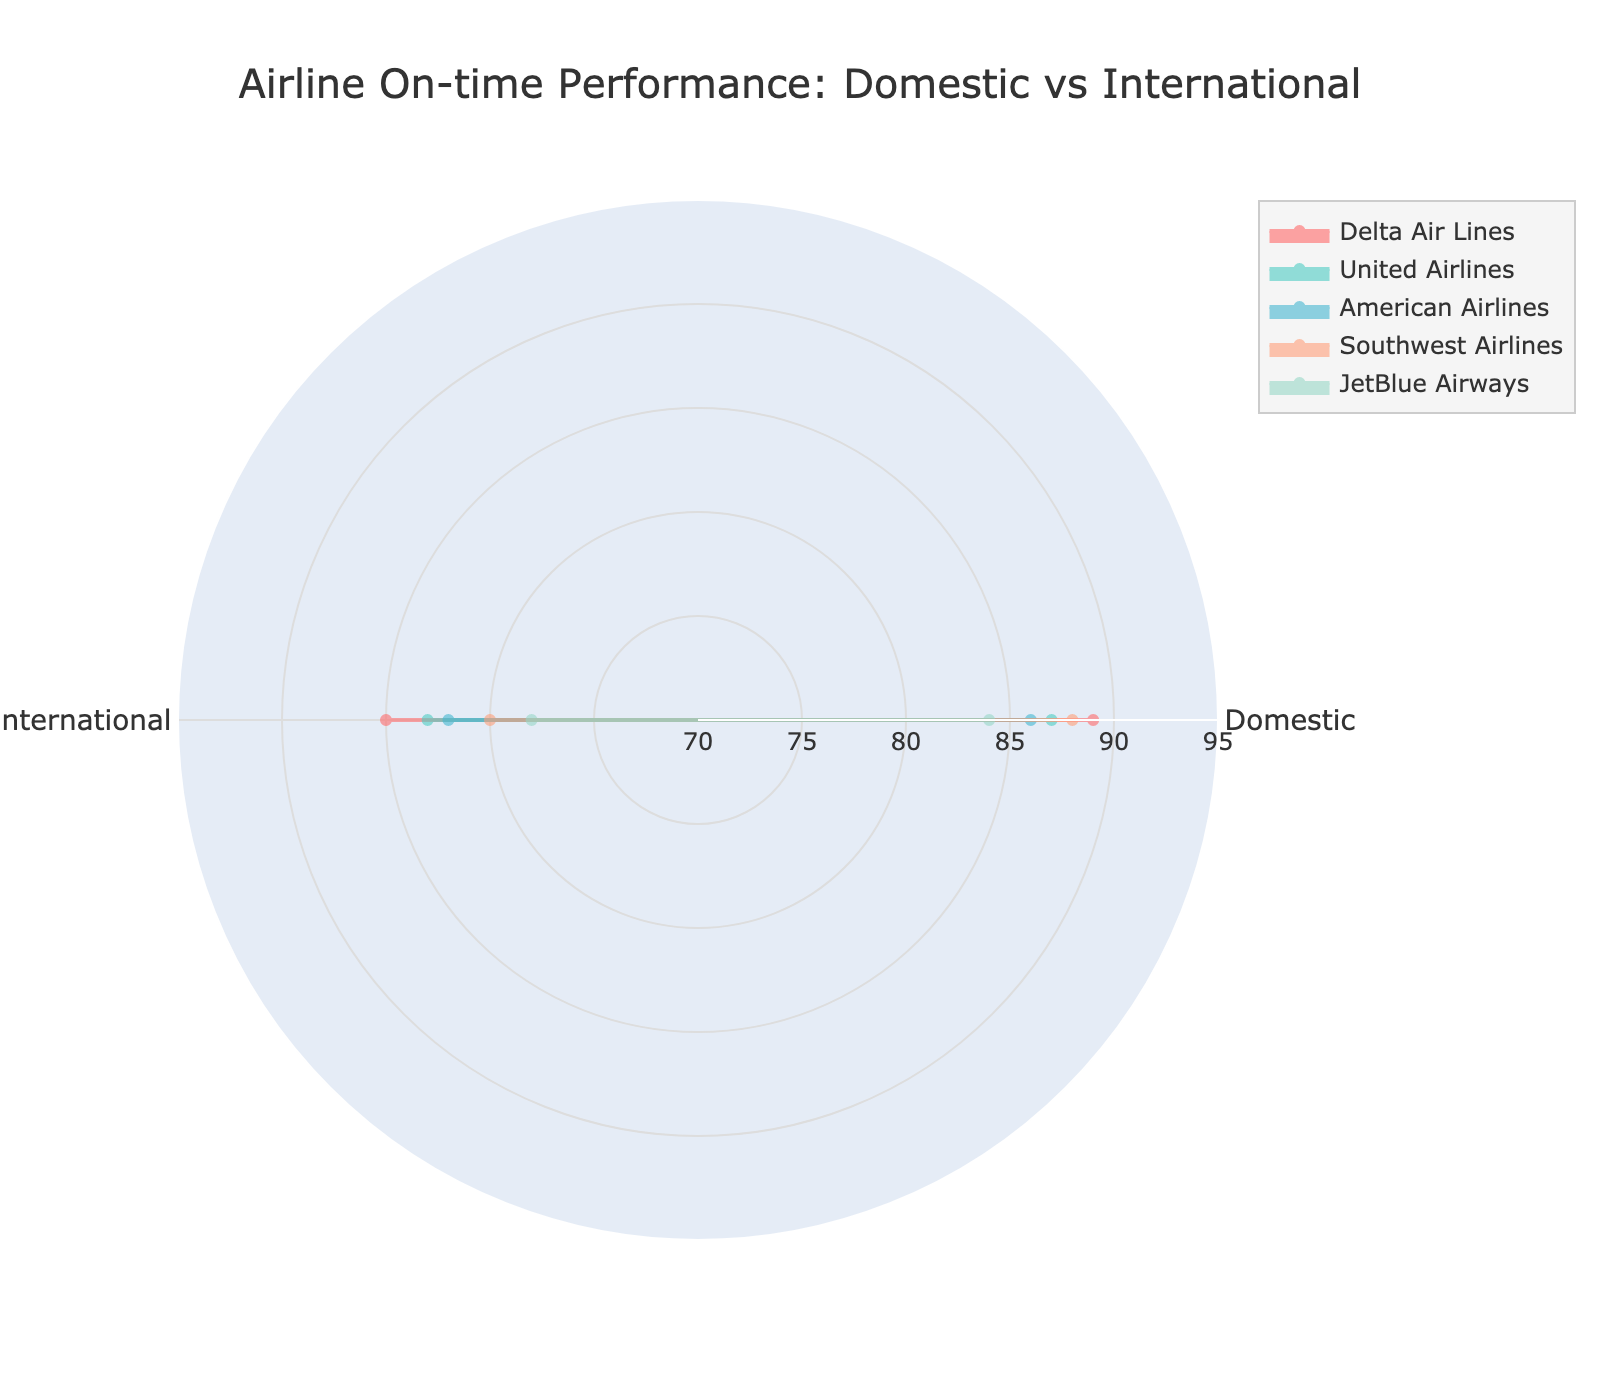What's the title of the radar chart? The title is displayed at the top center of the radar chart. It reads "Airline On-time Performance: Domestic vs International".
Answer: Airline On-time Performance: Domestic vs International How many categories of flights are shown in the radar chart? The radar chart has two categories that are displayed around the chart's axis. They are "Domestic" and "International".
Answer: 2 Which airline has the highest on-time performance for domestic flights? Compare the on-time performance values for domestic flights among all the airlines. Delta Air Lines has the highest value at 89.
Answer: Delta Air Lines What is the range of on-time performance percentages shown in the chart? The radial axis values range from 70 to 95, visible on the radar chart.
Answer: 70 to 95 Which airline has the largest discrepancy between its domestic and international on-time performance? Calculate the differences for each airline: Delta (89-85)=4, United (87-83)=4, American (86-82)=4, Southwest (88-80)=8, JetBlue (84-78)=6. Southwest Airlines has the largest discrepancy of 8.
Answer: Southwest Airlines How many airlines are represented in the radar chart? Count the distinct airlines based on the legend entries or the colored lines/areas in the chart. There are 5 airlines.
Answer: 5 What color represents JetBlue Airways in the radar chart? Identify the color each airline is associated with on the radar chart. JetBlue Airways is represented by a blue shade.
Answer: Blue Which airline has the lowest on-time performance for international flights? Compare the on-time performance values for international flights among all the airlines. JetBlue Airways has the lowest value at 78.
Answer: JetBlue Airways Among the airlines, which two have the same on-time performance for domestic flights? Check the on-time performance values for domestic flights and identify any matching values. Delta Air Lines and Southwest Airlines both have a performance of 88.
Answer: Delta Air Lines, Southwest Airlines 